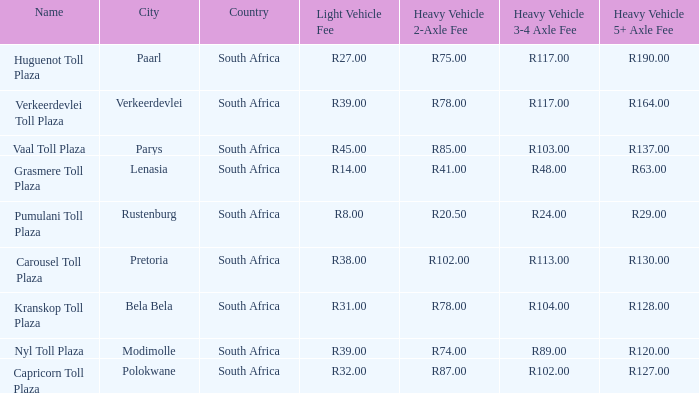What is the name of the plaza where the told for heavy vehicles with 2 axles is r20.50? Pumulani Toll Plaza. 